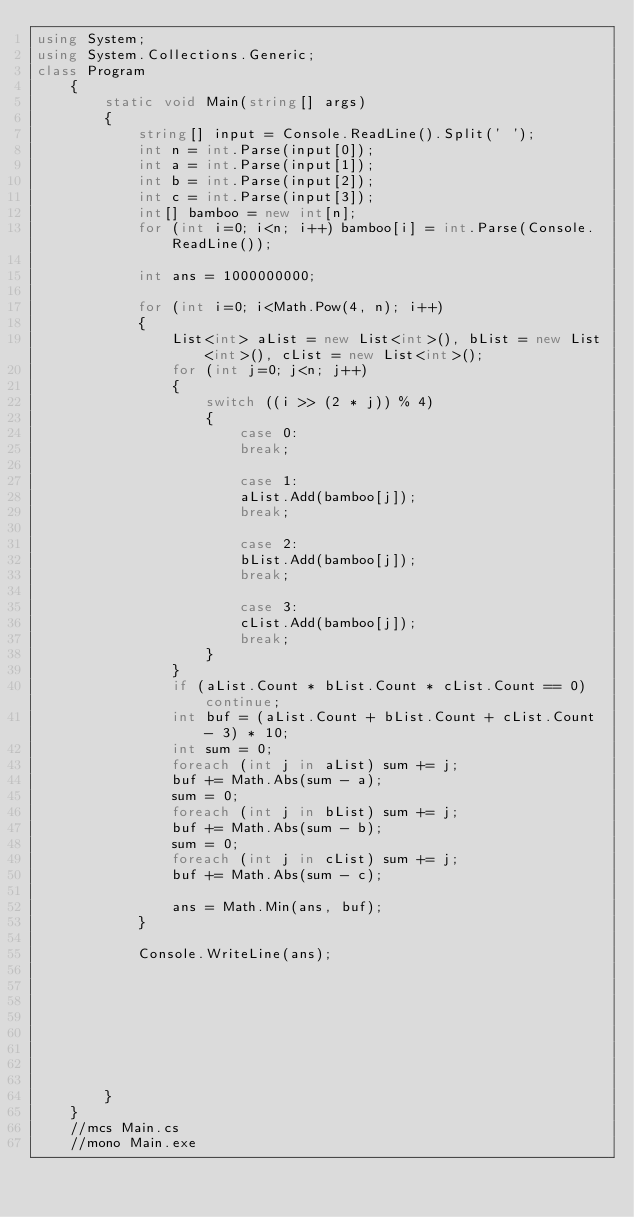Convert code to text. <code><loc_0><loc_0><loc_500><loc_500><_C#_>using System;
using System.Collections.Generic;
class Program
    {
        static void Main(string[] args)
        {
            string[] input = Console.ReadLine().Split(' ');
            int n = int.Parse(input[0]);
            int a = int.Parse(input[1]);
            int b = int.Parse(input[2]);
            int c = int.Parse(input[3]);
            int[] bamboo = new int[n];
            for (int i=0; i<n; i++) bamboo[i] = int.Parse(Console.ReadLine());

            int ans = 1000000000;

            for (int i=0; i<Math.Pow(4, n); i++)
            {
                List<int> aList = new List<int>(), bList = new List<int>(), cList = new List<int>();
                for (int j=0; j<n; j++)
                {
                    switch ((i >> (2 * j)) % 4)
                    {
                        case 0:
                        break;

                        case 1:
                        aList.Add(bamboo[j]);
                        break;

                        case 2:
                        bList.Add(bamboo[j]);
                        break;

                        case 3:
                        cList.Add(bamboo[j]);
                        break;
                    }
                }
                if (aList.Count * bList.Count * cList.Count == 0) continue;
                int buf = (aList.Count + bList.Count + cList.Count - 3) * 10;
                int sum = 0;
                foreach (int j in aList) sum += j;
                buf += Math.Abs(sum - a);
                sum = 0;
                foreach (int j in bList) sum += j;
                buf += Math.Abs(sum - b);
                sum = 0;
                foreach (int j in cList) sum += j;
                buf += Math.Abs(sum - c);

                ans = Math.Min(ans, buf);
            }

            Console.WriteLine(ans);



            
            

            
            
        }
    }
    //mcs Main.cs
    //mono Main.exe</code> 